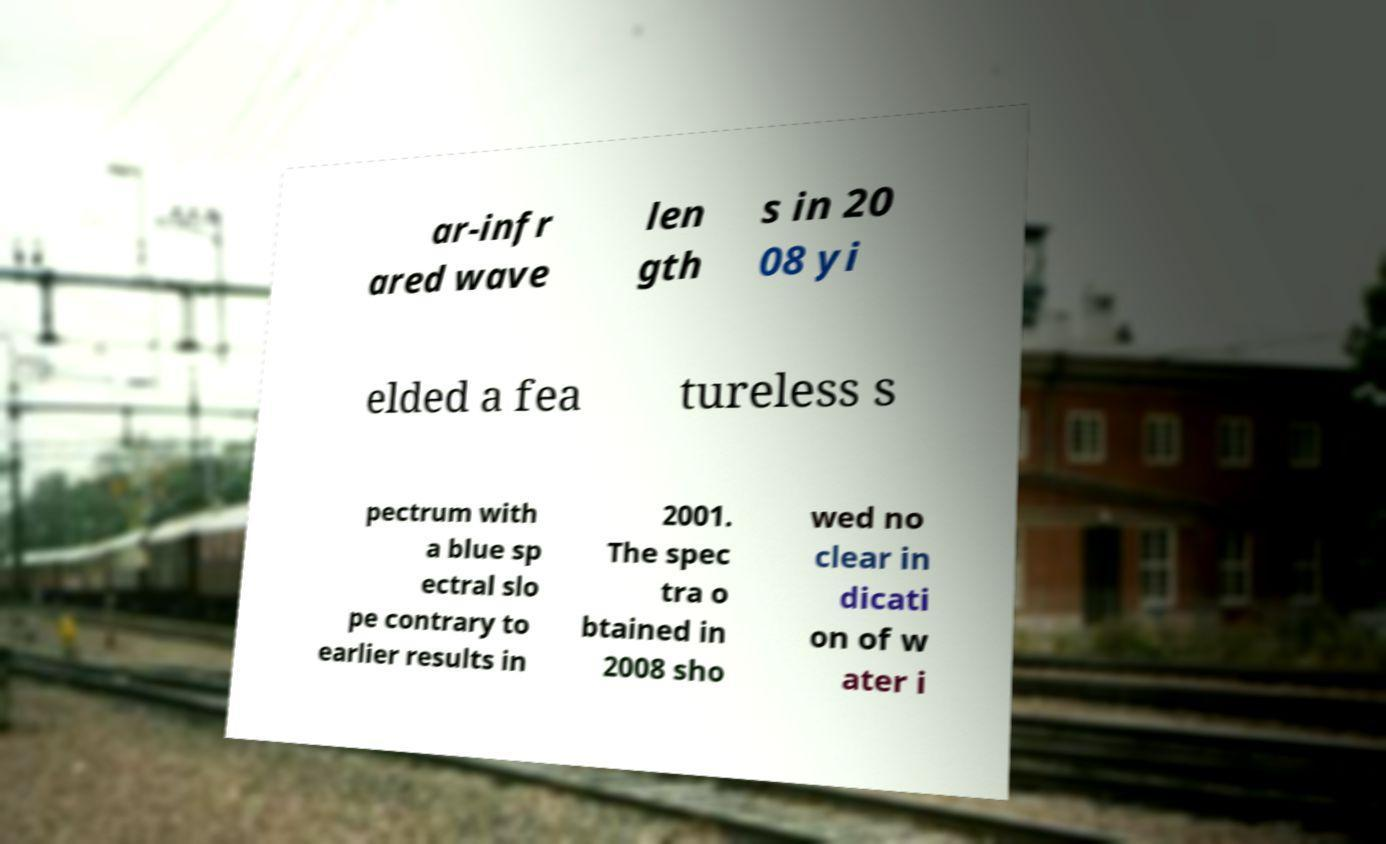Can you read and provide the text displayed in the image?This photo seems to have some interesting text. Can you extract and type it out for me? ar-infr ared wave len gth s in 20 08 yi elded a fea tureless s pectrum with a blue sp ectral slo pe contrary to earlier results in 2001. The spec tra o btained in 2008 sho wed no clear in dicati on of w ater i 